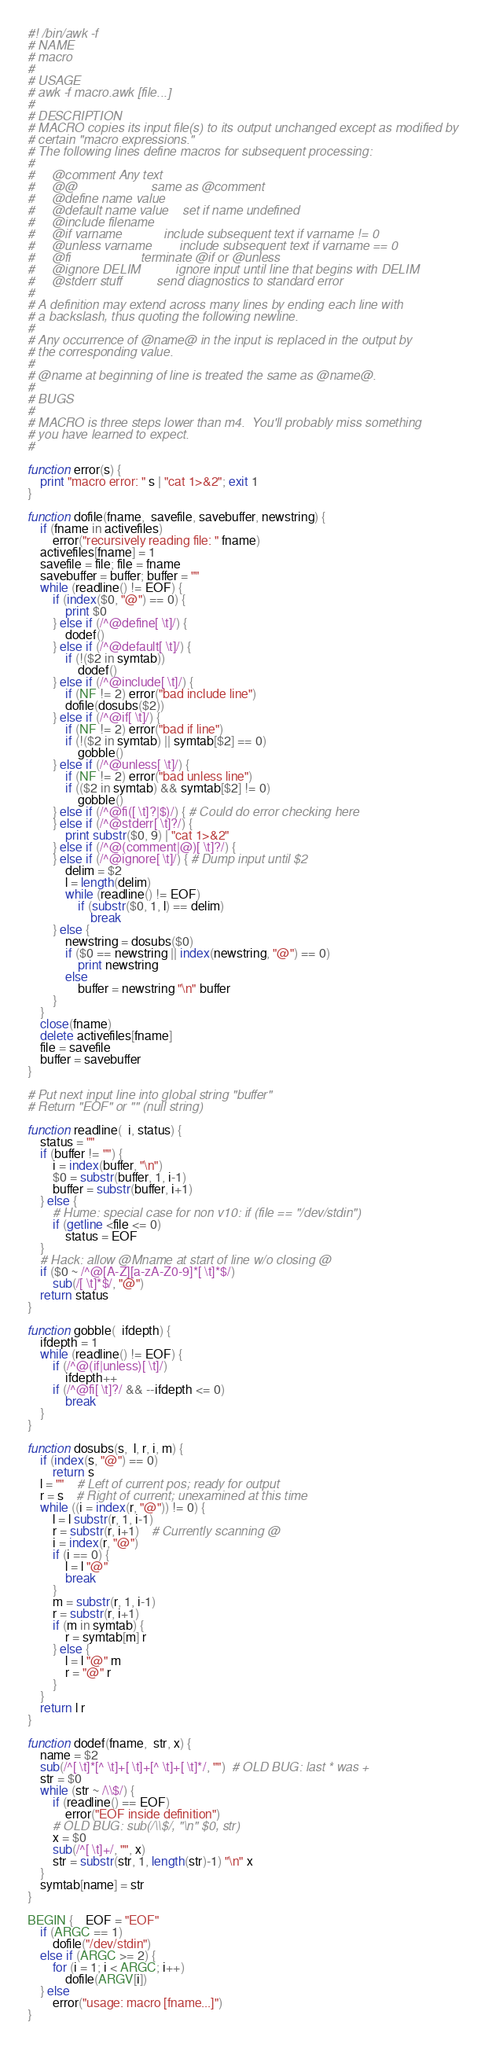Convert code to text. <code><loc_0><loc_0><loc_500><loc_500><_Awk_>#! /bin/awk -f# NAME# macro## USAGE# awk -f macro.awk [file...]## DESCRIPTION# MACRO copies its input file(s) to its output unchanged except as modified by# certain "macro expressions."  # The following lines define macros for subsequent processing:##     @comment Any text#     @@                     same as @comment#     @define name value#     @default name value    set if name undefined#     @include filename#     @if varname            include subsequent text if varname != 0#     @unless varname        include subsequent text if varname == 0#     @fi                    terminate @if or @unless#     @ignore DELIM          ignore input until line that begins with DELIM#     @stderr stuff          send diagnostics to standard error## A definition may extend across many lines by ending each line with# a backslash, thus quoting the following newline.## Any occurrence of @name@ in the input is replaced in the output by# the corresponding value.## @name at beginning of line is treated the same as @name@.## BUGS## MACRO is three steps lower than m4.  You'll probably miss something# you have learned to expect.#function error(s) {	print "macro error: " s | "cat 1>&2"; exit 1}function dofile(fname,  savefile, savebuffer, newstring) {	if (fname in activefiles)		error("recursively reading file: " fname)	activefiles[fname] = 1	savefile = file; file = fname	savebuffer = buffer; buffer = ""	while (readline() != EOF) {		if (index($0, "@") == 0) {			print $0		} else if (/^@define[ \t]/) {			dodef()		} else if (/^@default[ \t]/) {			if (!($2 in symtab))				dodef()		} else if (/^@include[ \t]/) {			if (NF != 2) error("bad include line")			dofile(dosubs($2))		} else if (/^@if[ \t]/) {			if (NF != 2) error("bad if line")			if (!($2 in symtab) || symtab[$2] == 0)				gobble()		} else if (/^@unless[ \t]/) {			if (NF != 2) error("bad unless line")			if (($2 in symtab) && symtab[$2] != 0)				gobble()		} else if (/^@fi([ \t]?|$)/) { # Could do error checking here		} else if (/^@stderr[ \t]?/) {			print substr($0, 9) | "cat 1>&2"		} else if (/^@(comment|@)[ \t]?/) {		} else if (/^@ignore[ \t]/) { # Dump input until $2			delim = $2			l = length(delim)			while (readline() != EOF)				if (substr($0, 1, l) == delim)					break		} else {			newstring = dosubs($0)			if ($0 == newstring || index(newstring, "@") == 0)				print newstring			else				buffer = newstring "\n" buffer		}	}	close(fname)	delete activefiles[fname]	file = savefile	buffer = savebuffer}# Put next input line into global string "buffer"# Return "EOF" or "" (null string)function readline(  i, status) {	status = ""	if (buffer != "") {		i = index(buffer, "\n")		$0 = substr(buffer, 1, i-1)		buffer = substr(buffer, i+1)	} else {		# Hume: special case for non v10: if (file == "/dev/stdin")		if (getline <file <= 0)			status = EOF	}	# Hack: allow @Mname at start of line w/o closing @	if ($0 ~ /^@[A-Z][a-zA-Z0-9]*[ \t]*$/)		sub(/[ \t]*$/, "@")	return status}function gobble(  ifdepth) {	ifdepth = 1	while (readline() != EOF) {		if (/^@(if|unless)[ \t]/)			ifdepth++		if (/^@fi[ \t]?/ && --ifdepth <= 0)			break	}}function dosubs(s,  l, r, i, m) {	if (index(s, "@") == 0)		return s	l = ""	# Left of current pos; ready for output	r = s	# Right of current; unexamined at this time	while ((i = index(r, "@")) != 0) {		l = l substr(r, 1, i-1)		r = substr(r, i+1)	# Currently scanning @		i = index(r, "@")		if (i == 0) {			l = l "@"			break		}		m = substr(r, 1, i-1)		r = substr(r, i+1)		if (m in symtab) {			r = symtab[m] r		} else {			l = l "@" m			r = "@" r		}	}	return l r}function dodef(fname,  str, x) {	name = $2	sub(/^[ \t]*[^ \t]+[ \t]+[^ \t]+[ \t]*/, "")  # OLD BUG: last * was +	str = $0	while (str ~ /\\$/) {		if (readline() == EOF)			error("EOF inside definition")		# OLD BUG: sub(/\\$/, "\n" $0, str)		x = $0		sub(/^[ \t]+/, "", x)		str = substr(str, 1, length(str)-1) "\n" x	}	symtab[name] = str}BEGIN {	EOF = "EOF"	if (ARGC == 1)		dofile("/dev/stdin")	else if (ARGC >= 2) {		for (i = 1; i < ARGC; i++)			dofile(ARGV[i])	} else		error("usage: macro [fname...]")}</code> 